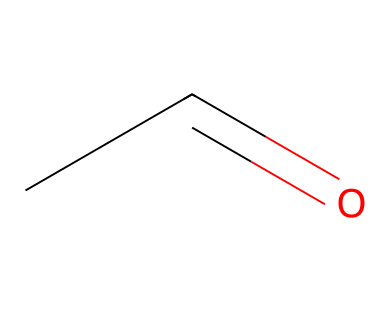What is the name of this chemical? The SMILES representation "CC=O" corresponds to the molecular structure known as acetaldehyde.
Answer: acetaldehyde How many carbon atoms are in acetaldehyde? The structure has two carbon atoms, as observed from "CC" in the SMILES notation.
Answer: 2 How many double bonds are in this molecule? There is one double bond present between the carbon and oxygen, indicated by the "=" in the SMILES ("CC=O").
Answer: 1 What functional group is present in acetaldehyde? The structure features a carbonyl group (C=O), which is characteristic of aldehydes.
Answer: carbonyl What type of chemical is acetaldehyde classified as? Acetaldehyde is categorized as an aldehyde due to the presence of the carbonyl group at the end of the carbon chain.
Answer: aldehyde How many hydrogen atoms are present in acetaldehyde? For the structure "CC=O," there are four hydrogen atoms bound to the two carbon atoms, as derived from its molecular formula (C2H4O).
Answer: 4 Why is acetaldehyde significant in the context of alcohol metabolism? Acetaldehyde is an important byproduct of alcohol metabolism, which is relevant to the effects of drinking during events and can influence drink choices.
Answer: byproduct 